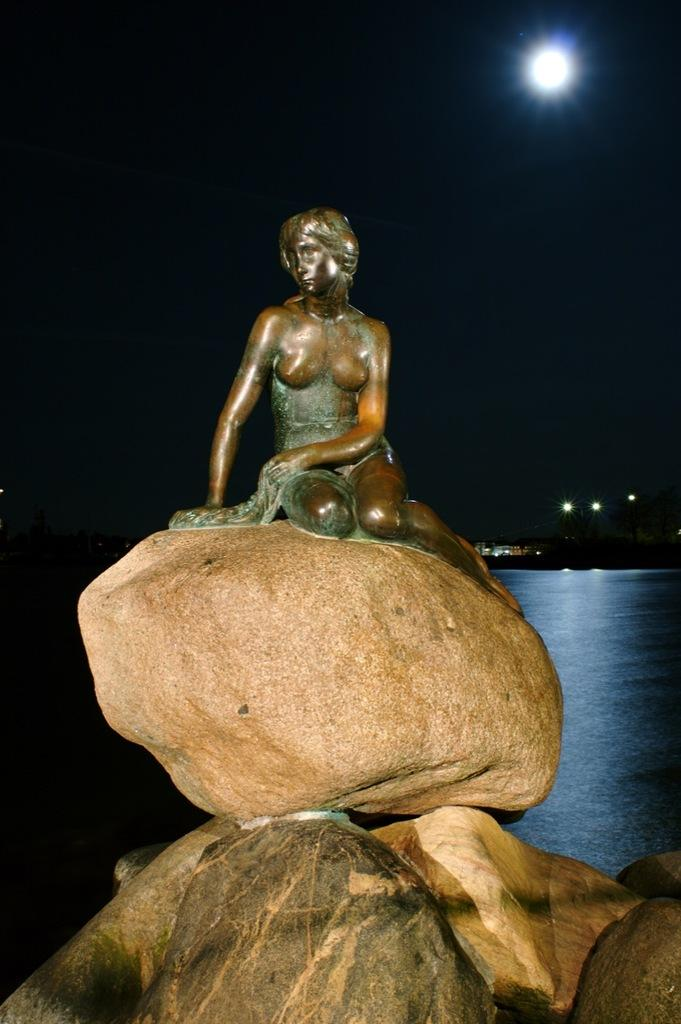What is located on a rock in the image? There is a statue on a rock in the image. What can be seen in the water body in the image? There is a ship in a water body in the image. What is providing illumination in the image? There are lights visible in the image. What celestial body is visible in the sky in the image? The moon is visible in the sky in the image. What type of pencil is being used to draw the ship in the image? There is no pencil present in the image, and the ship is not being drawn. What is the ship using to collect oil in the image? There is no mention of oil or any oil-collecting activity in the image. 